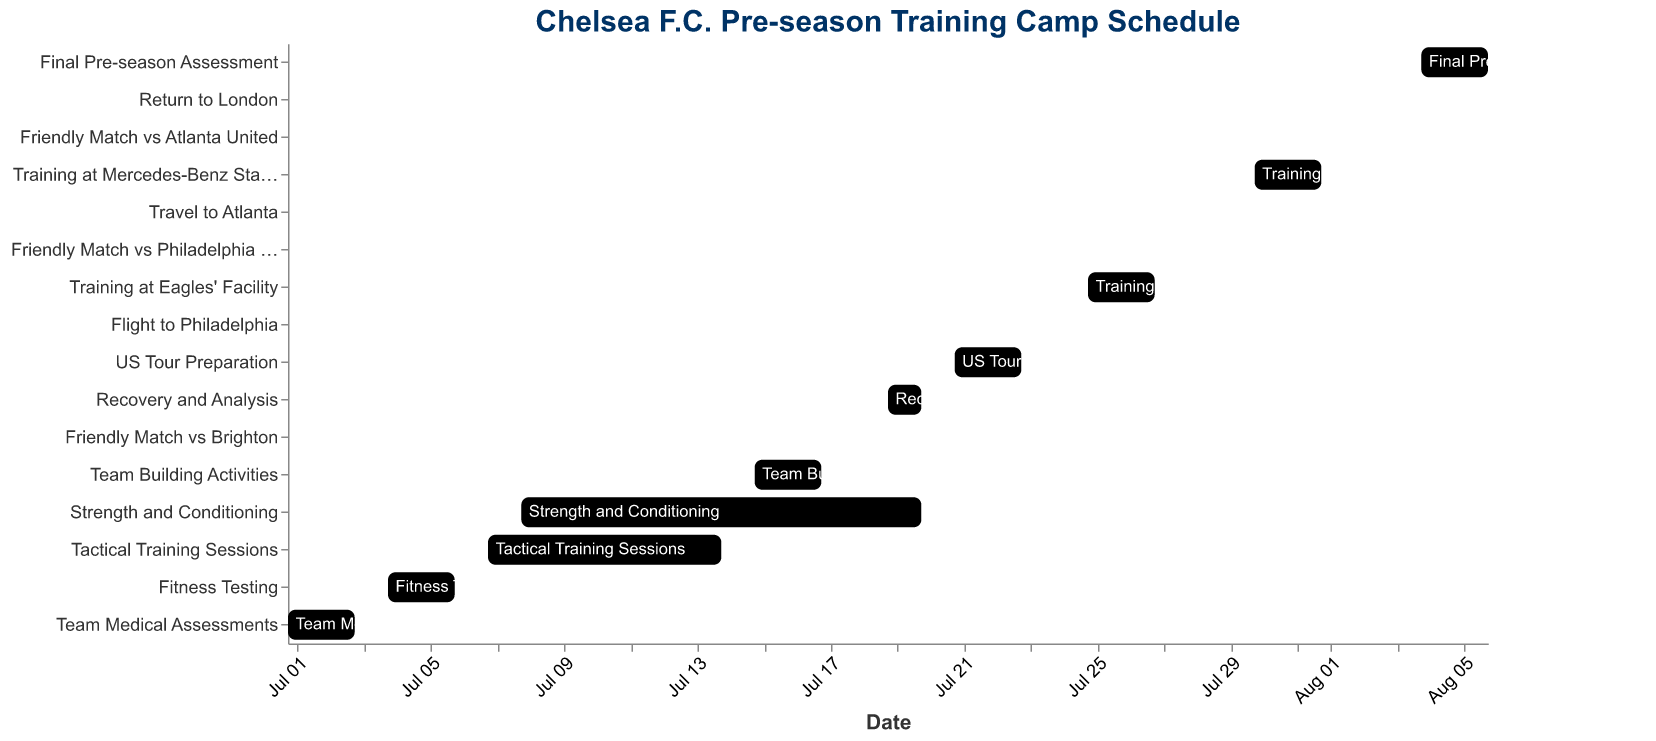What's the title of the chart? The title is usually displayed prominently at the top of the chart. In this case, it is mentioned in the "title" attribute within the code.
Answer: Chelsea F.C. Pre-season Training Camp Schedule Which activities overlap with Tactical Training Sessions? Look at the time range for Tactical Training Sessions and compare it to other tasks. Tactical Training Sessions run from 2023-07-07 to 2023-07-14. Strength and Conditioning (2023-07-08 to 2023-07-20) overlaps during this period.
Answer: Strength and Conditioning How many days is the Team Medical Assessments activity scheduled for? Find the start and end dates for Team Medical Assessments. The start date is 2023-07-01 and the end date is 2023-07-03. The duration is calculated by counting the days from start to end, inclusively.
Answer: 3 days Which activity has the shortest duration? Look at the start and end dates for each activity. Friendly Match vs Brighton is scheduled on a single day, making it the shortest.
Answer: Friendly Match vs Brighton Which tasks begin after the Tactical Training Sessions end? The Tactical Training Sessions end on 2023-07-14. Find tasks with start dates after 2023-07-14, such as Team Building Activities (2023-07-15).
Answer: Team Building Activities, Friendly Match vs Brighton, Recovery and Analysis, US Tour Preparation, Flight to Philadelphia, Training at Eagles' Facility, Friendly Match vs Philadelphia Union, Travel to Atlanta, Training at Mercedes-Benz Stadium, Friendly Match vs Atlanta United, Return to London, Final Pre-season Assessment How many tasks are scheduled in July? Count all activities with both start and end dates within July. Those are: Team Medical Assessments, Fitness Testing, Tactical Training Sessions, Strength and Conditioning, Team Building Activities, Friendly Match vs Brighton, Recovery and Analysis, US Tour Preparation, Flight to Philadelphia, Training at Eagles' Facility, Friendly Match vs Philadelphia Union, Travel to Atlanta, Training at Mercedes-Benz Stadium.
Answer: 13 tasks Compare the duration of Strength and Conditioning with Training at Mercedes-Benz Stadium. Which is longer? Calculate the duration for both activities. Strength and Conditioning runs from 2023-07-08 to 2023-07-20, giving it a duration of 13 days. Training at Mercedes-Benz Stadium runs from 2023-07-30 to 2023-08-01, giving it a duration of 3 days.
Answer: Strength and Conditioning What is the total number of friendly matches scheduled during the pre-season? Identify all activities labeled as a friendly match. These are: Friendly Match vs Brighton, Friendly Match vs Philadelphia Union, and Friendly Match vs Atlanta United.
Answer: 3 friendly matches When does the Final Pre-season Assessment occur? Find the start and end dates for the Final Pre-season Assessment activity. The start date is 2023-08-04 and the end date is 2023-08-06.
Answer: 2023-08-04 to 2023-08-06 How many days are allocated for Team Building Activities? Team Building Activities start on 2023-07-15 and end on 2023-07-17. Counting the inclusive days gives us 3 days.
Answer: 3 days 